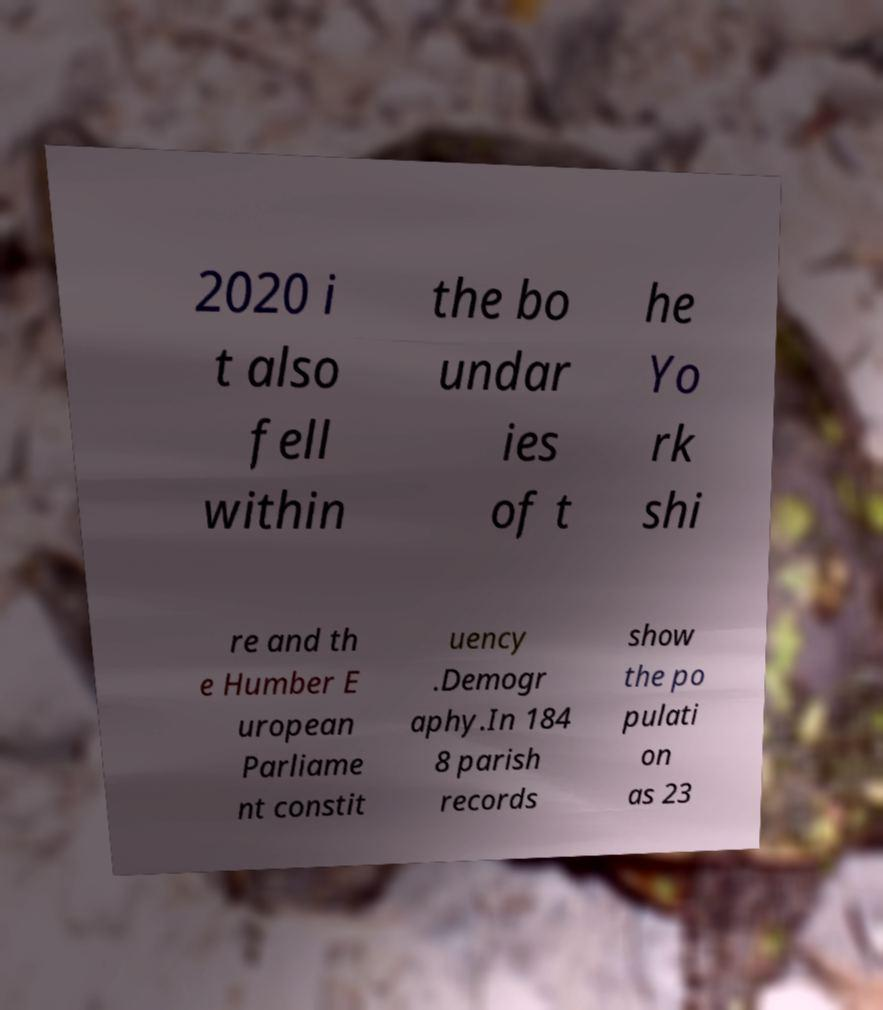Please identify and transcribe the text found in this image. 2020 i t also fell within the bo undar ies of t he Yo rk shi re and th e Humber E uropean Parliame nt constit uency .Demogr aphy.In 184 8 parish records show the po pulati on as 23 